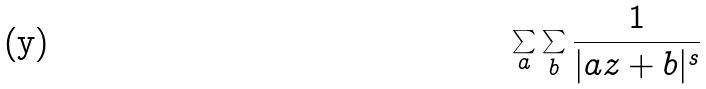Convert formula to latex. <formula><loc_0><loc_0><loc_500><loc_500>\sum _ { a } \sum _ { b } \frac { 1 } { | a z + b | ^ { s } }</formula> 